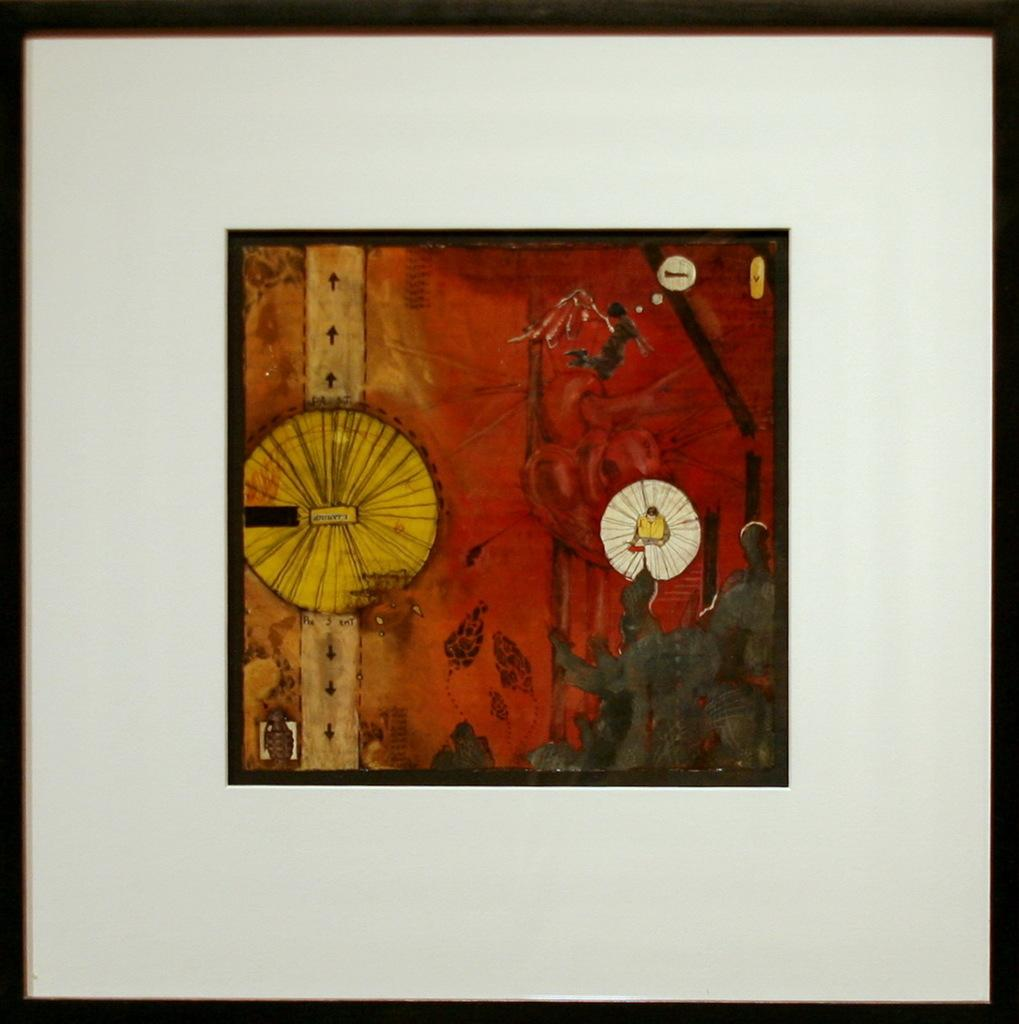What object is present in the image that typically holds a picture or artwork? There is a picture frame in the image. What is displayed within the frame? There is a painting in the center of the frame. What color is the frame surrounding the painting? The frame surrounding the painting is white. Where is the kitty performing on stage in the image? There is no kitty or stage present in the image; it only features a picture frame with a painting. 